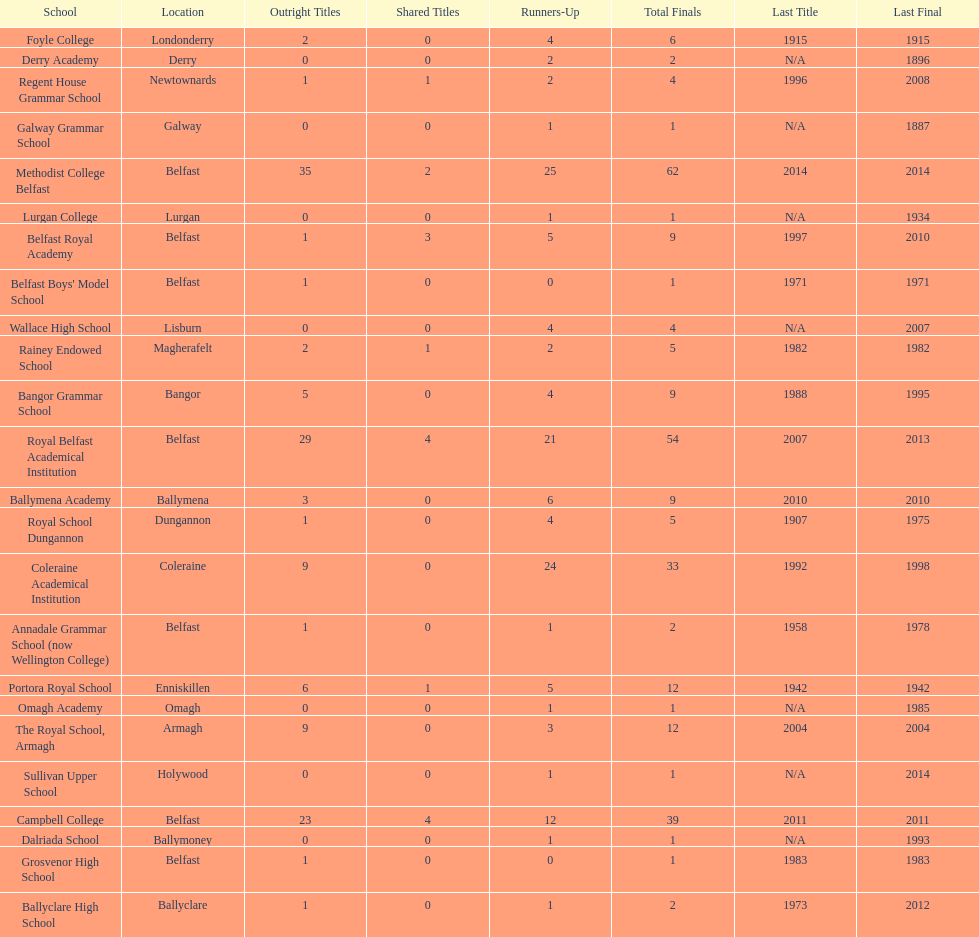Which school has the same number of outright titles as the coleraine academical institution? The Royal School, Armagh. 